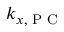<formula> <loc_0><loc_0><loc_500><loc_500>k _ { x , P C }</formula> 